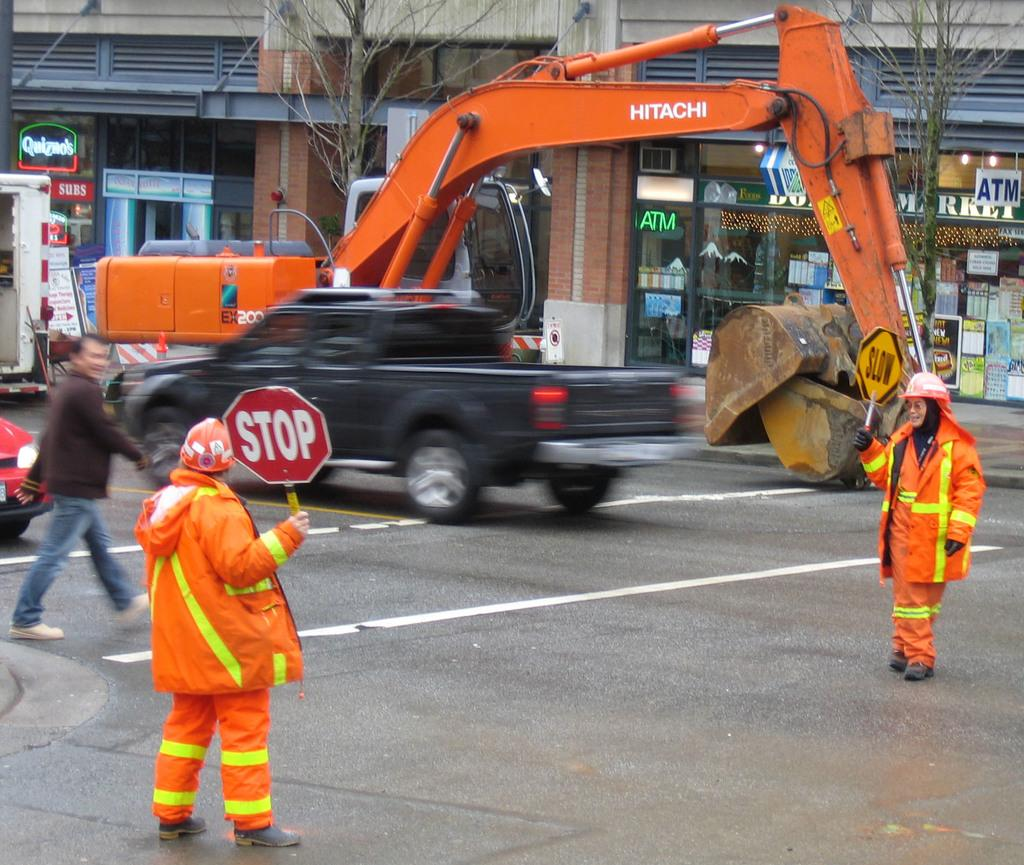What is happening on the road in the image? There are vehicles and people on the road in the image. What are the two persons holding in the image? The two persons are holding boards in the image. What can be seen in the background of the image? There are trees and buildings with boards visible in the background of the image. Is it raining in the image, and can you see any boats? There is no indication of rain in the image, and no boats are visible. 